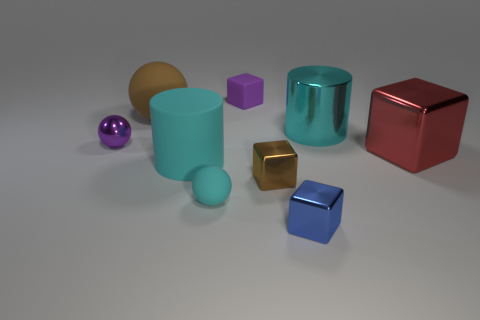Subtract all big blocks. How many blocks are left? 3 Add 1 red rubber cubes. How many objects exist? 10 Subtract all cyan balls. How many balls are left? 2 Subtract all balls. How many objects are left? 6 Subtract all gray rubber cubes. Subtract all big matte cylinders. How many objects are left? 8 Add 3 brown spheres. How many brown spheres are left? 4 Add 9 blue cubes. How many blue cubes exist? 10 Subtract 1 cyan spheres. How many objects are left? 8 Subtract 1 cylinders. How many cylinders are left? 1 Subtract all brown cylinders. Subtract all green blocks. How many cylinders are left? 2 